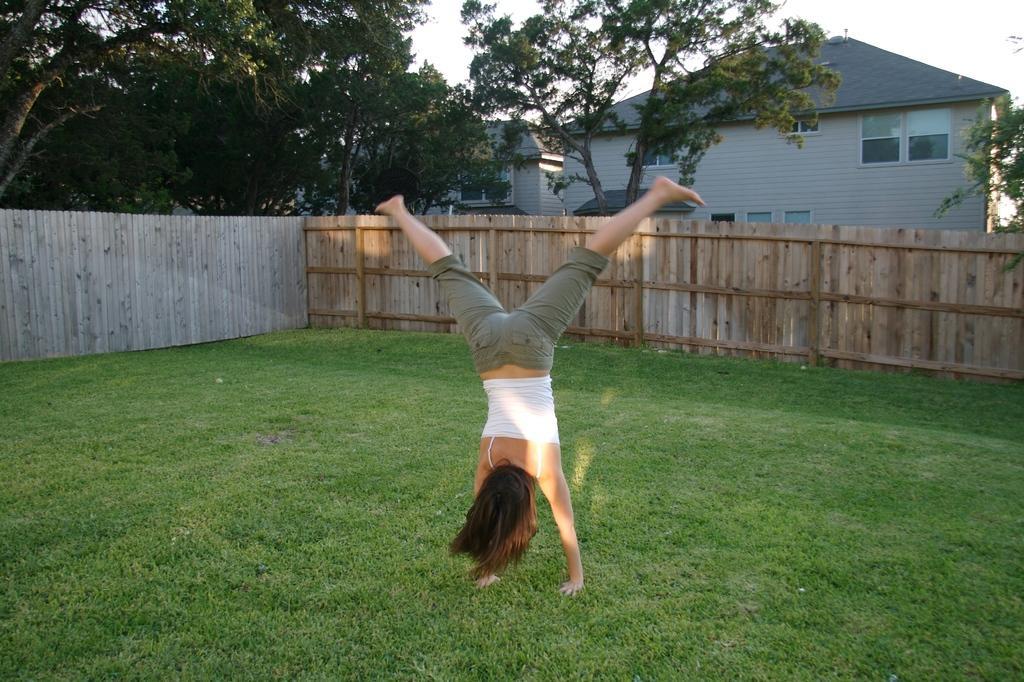How would you summarize this image in a sentence or two? A woman is doing exercise, she wore white color top. This is the grass and this is the wooden compound wall, in the left side there are green color trees. There is a building in the right side of an image. 